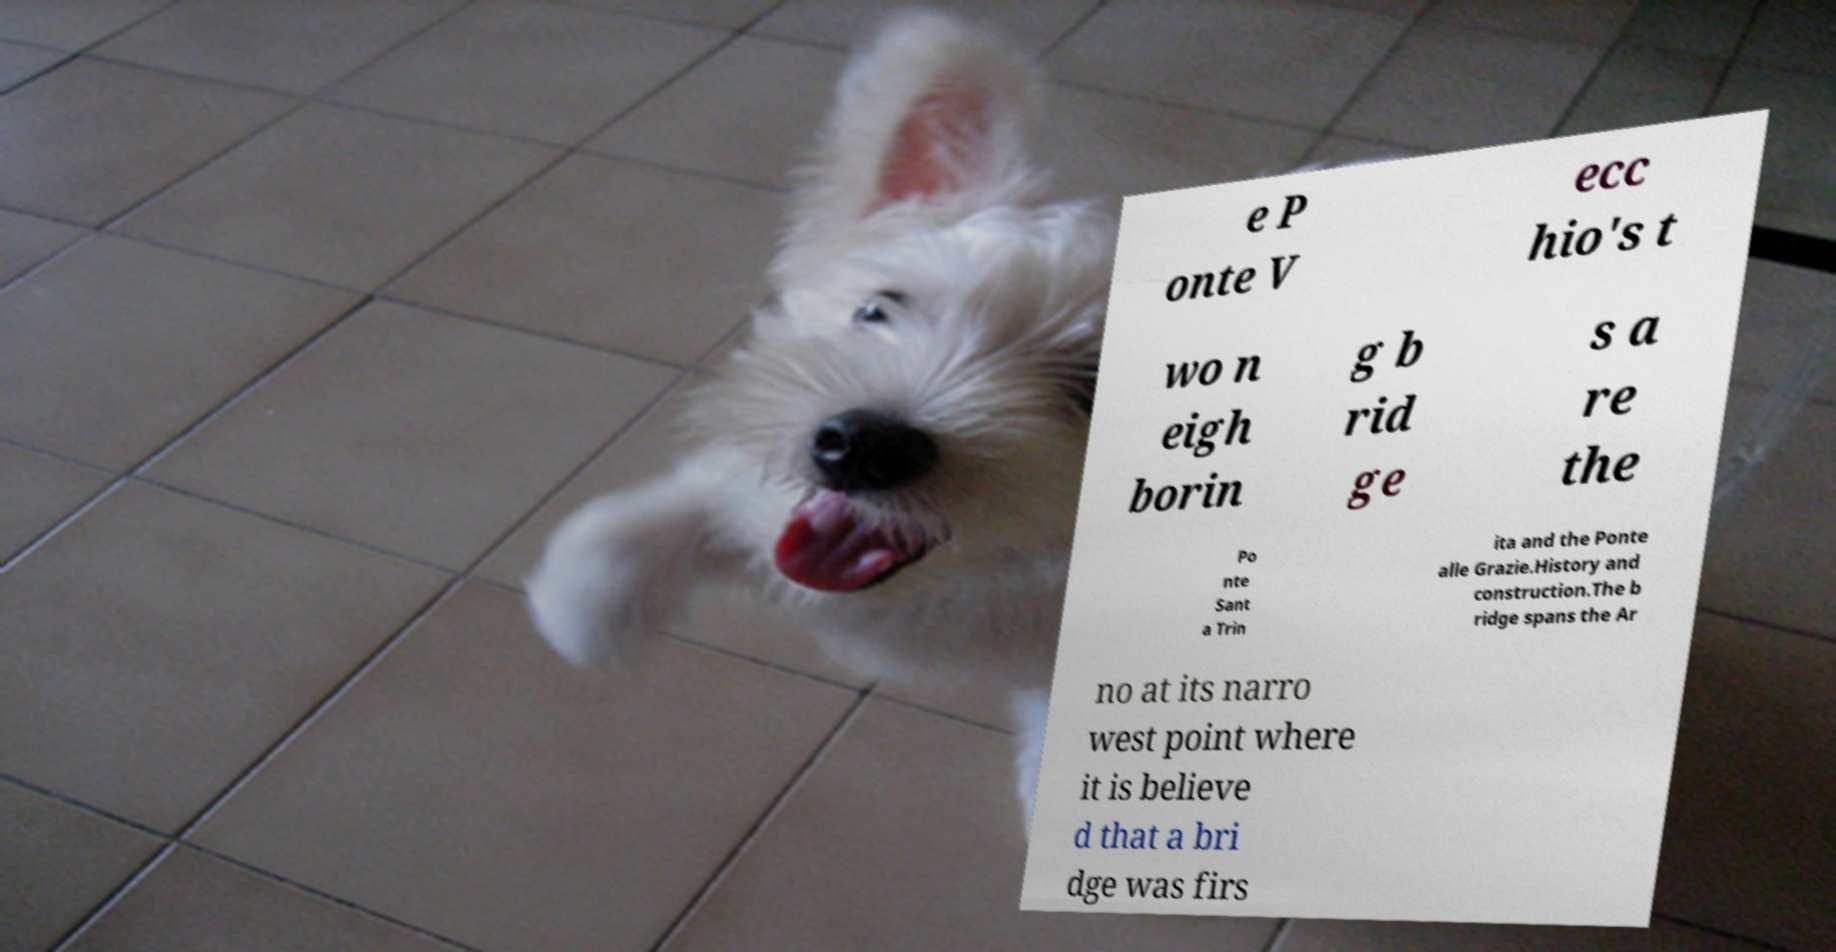There's text embedded in this image that I need extracted. Can you transcribe it verbatim? e P onte V ecc hio's t wo n eigh borin g b rid ge s a re the Po nte Sant a Trin ita and the Ponte alle Grazie.History and construction.The b ridge spans the Ar no at its narro west point where it is believe d that a bri dge was firs 